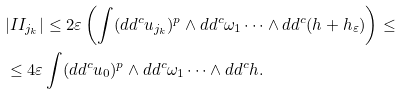Convert formula to latex. <formula><loc_0><loc_0><loc_500><loc_500>& | I I _ { j _ { k } } | \leq 2 \varepsilon \left ( \int ( d d ^ { c } u _ { j _ { k } } ) ^ { p } \land d d ^ { c } \omega _ { 1 } \dots \land d d ^ { c } ( h + h _ { \varepsilon } ) \right ) \leq \\ & \leq 4 \varepsilon \int ( d d ^ { c } u _ { 0 } ) ^ { p } \land d d ^ { c } \omega _ { 1 } \dots \land d d ^ { c } h .</formula> 